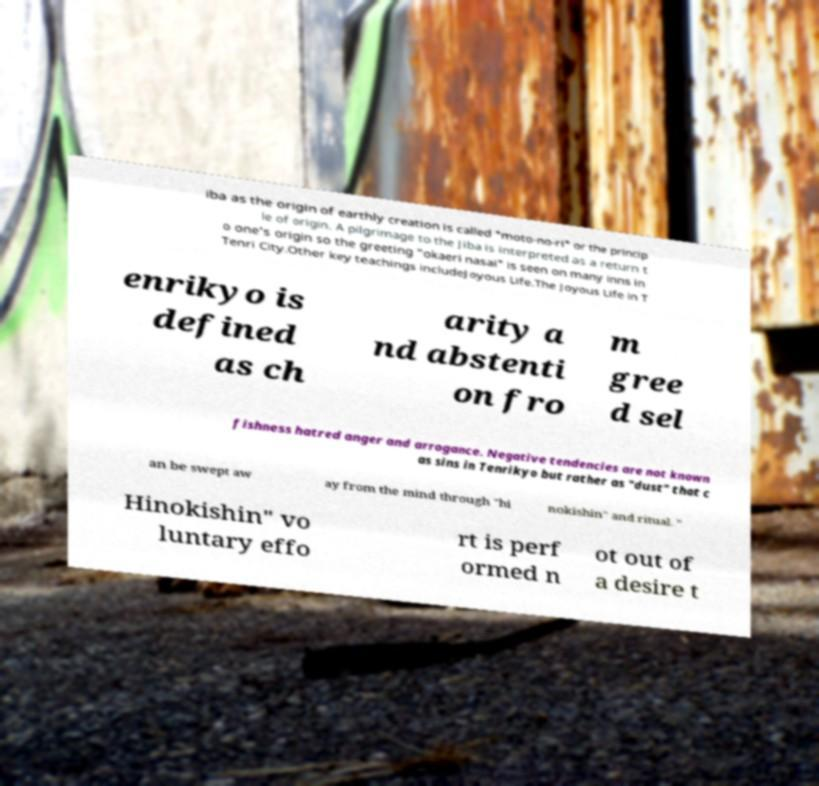For documentation purposes, I need the text within this image transcribed. Could you provide that? iba as the origin of earthly creation is called "moto-no-ri" or the princip le of origin. A pilgrimage to the Jiba is interpreted as a return t o one's origin so the greeting "okaeri nasai" is seen on many inns in Tenri City.Other key teachings includeJoyous Life.The Joyous Life in T enrikyo is defined as ch arity a nd abstenti on fro m gree d sel fishness hatred anger and arrogance. Negative tendencies are not known as sins in Tenrikyo but rather as "dust" that c an be swept aw ay from the mind through "hi nokishin" and ritual. " Hinokishin" vo luntary effo rt is perf ormed n ot out of a desire t 